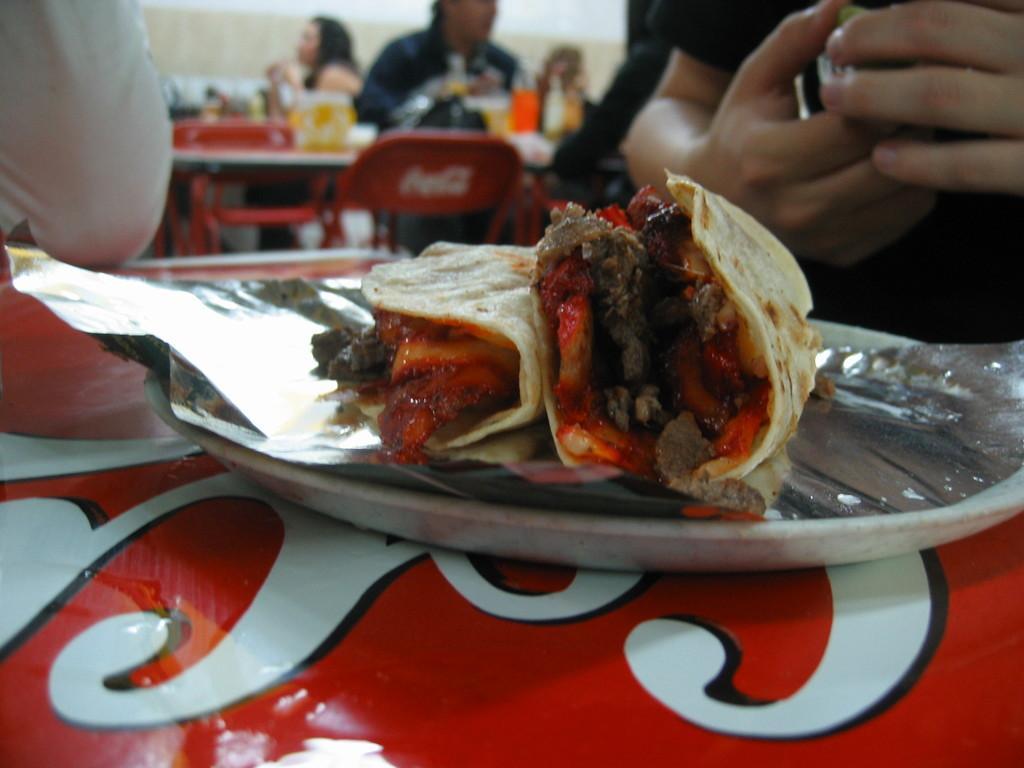Describe this image in one or two sentences. In this image, we can see some food on the silver foil. Here there is a plate and some text on the red surface. Top of the image, we can see few people, chairs, table and few objects. Here there is a wall. On the right side top corner, we can see a person is holding an object. 